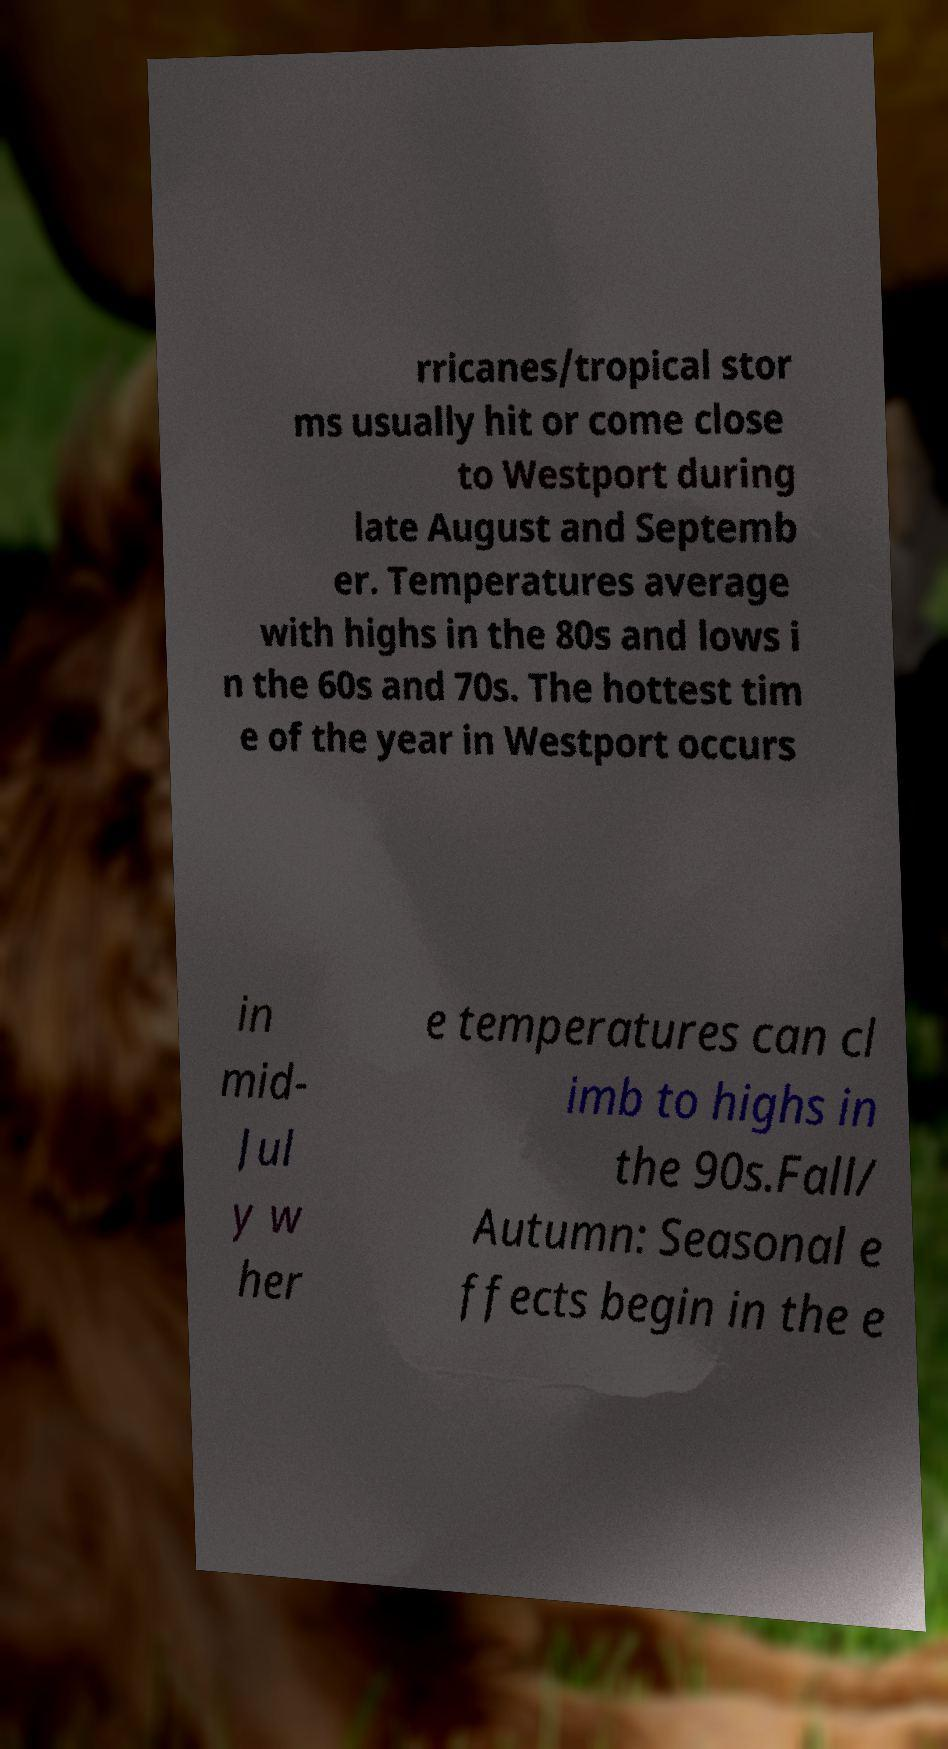Can you read and provide the text displayed in the image?This photo seems to have some interesting text. Can you extract and type it out for me? rricanes/tropical stor ms usually hit or come close to Westport during late August and Septemb er. Temperatures average with highs in the 80s and lows i n the 60s and 70s. The hottest tim e of the year in Westport occurs in mid- Jul y w her e temperatures can cl imb to highs in the 90s.Fall/ Autumn: Seasonal e ffects begin in the e 